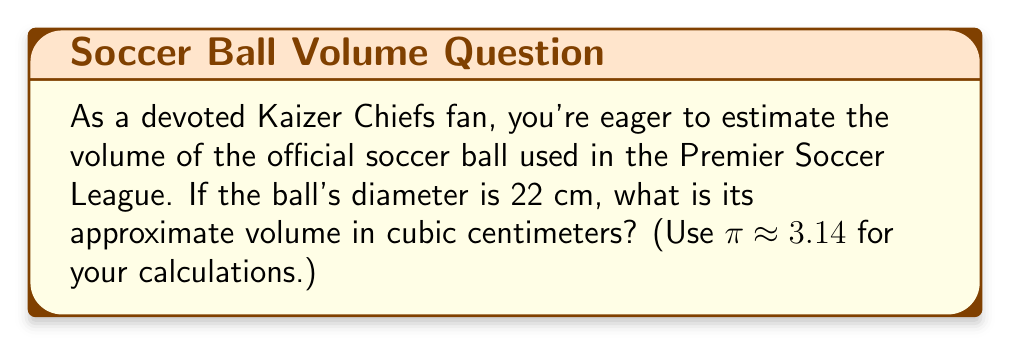Give your solution to this math problem. Let's approach this step-by-step:

1) The formula for the volume of a sphere is:
   $$V = \frac{4}{3}\pi r^3$$
   where $r$ is the radius of the sphere.

2) We're given the diameter, which is 22 cm. The radius is half of the diameter:
   $$r = \frac{22}{2} = 11 \text{ cm}$$

3) Now, let's substitute this into our formula:
   $$V = \frac{4}{3}\pi (11)^3$$

4) Simplify the cube:
   $$V = \frac{4}{3}\pi (1331)$$

5) Multiply:
   $$V = \frac{4}{3} \times 3.14 \times 1331$$

6) Calculate:
   $$V \approx 5575.41 \text{ cm}^3$$

7) Rounding to the nearest whole number:
   $$V \approx 5575 \text{ cm}^3$$
Answer: $5575 \text{ cm}^3$ 